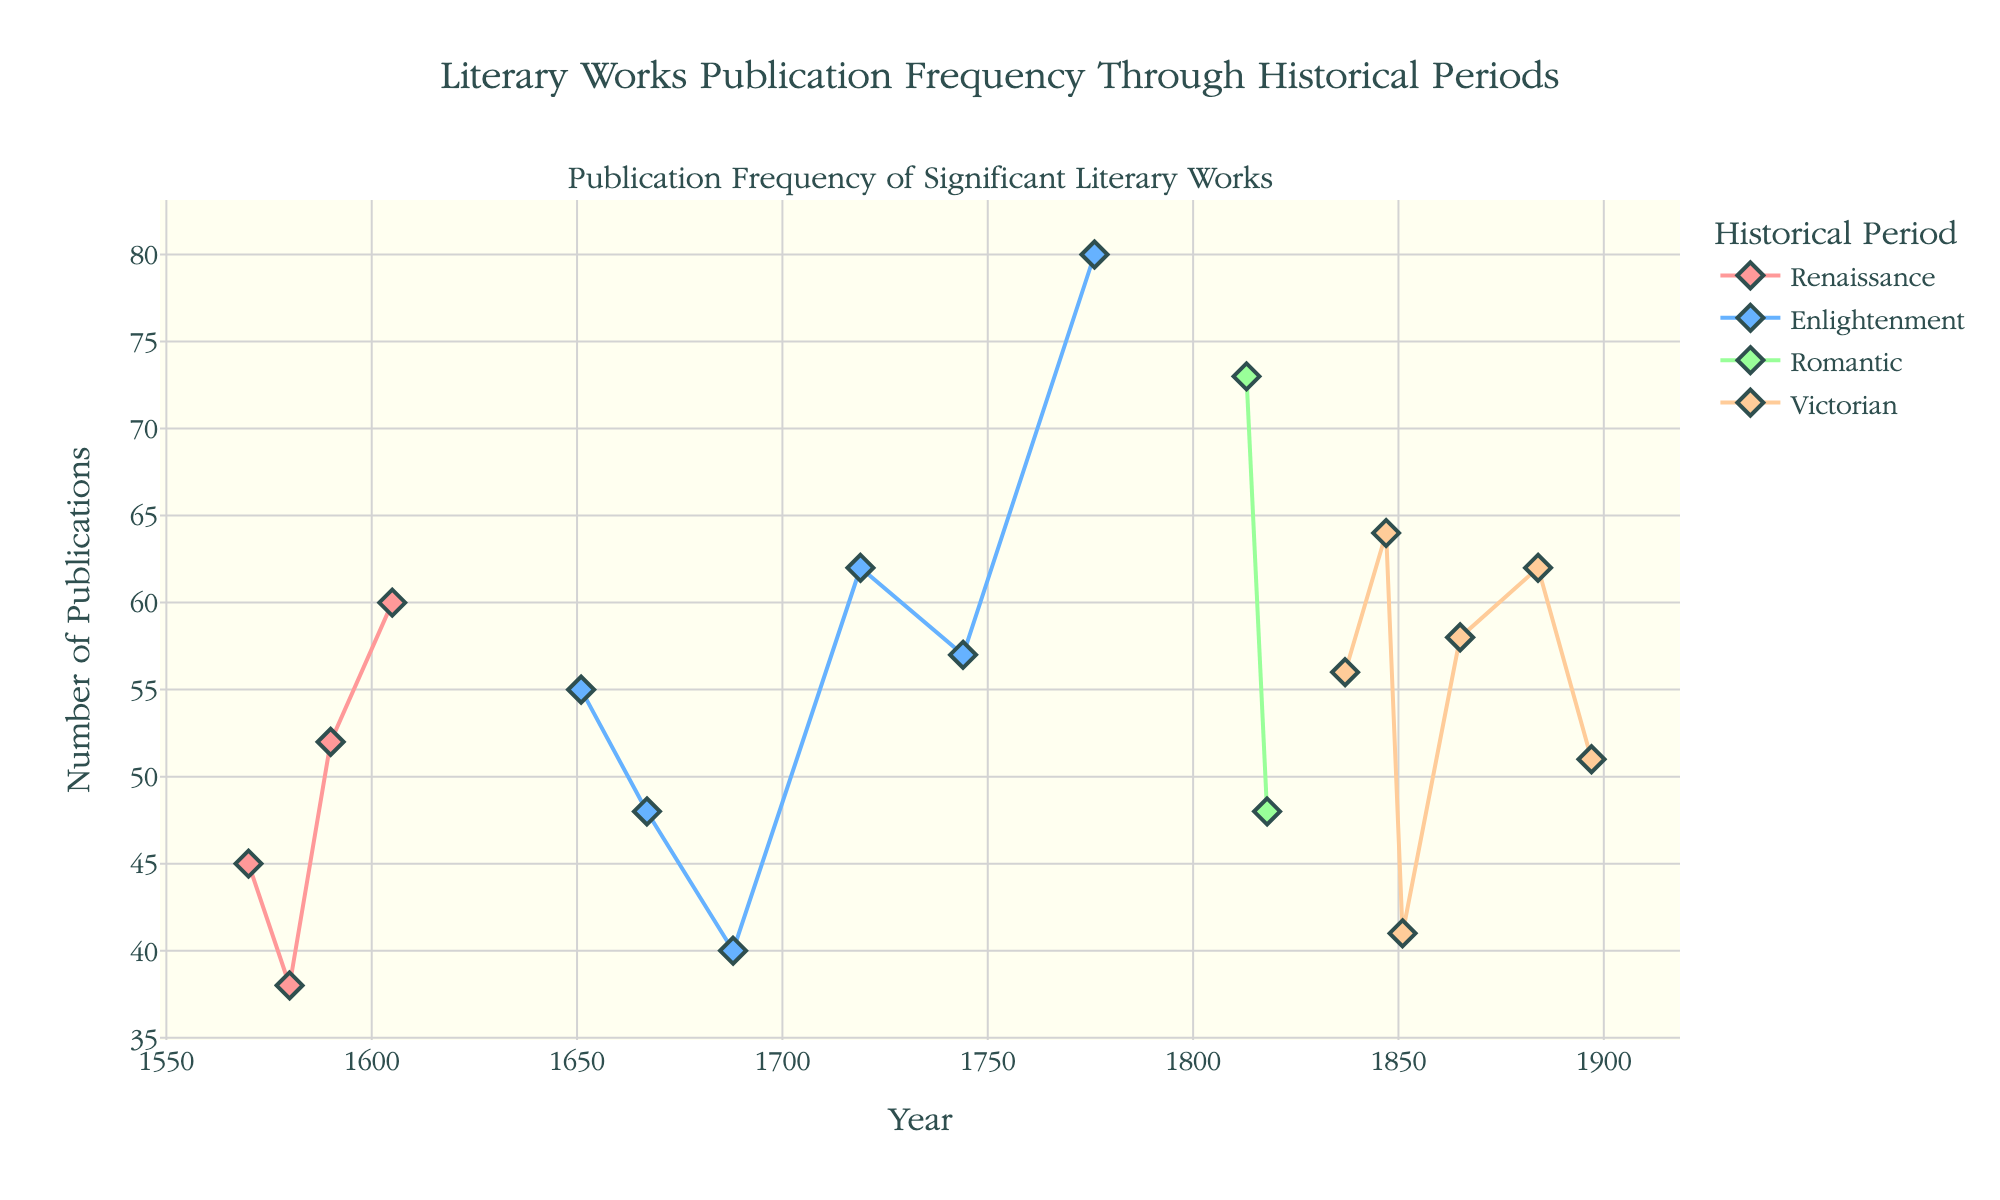Which period has the highest publication frequency for a single work? The chart shows each period's data points representing significant literary works and their publication frequencies. The data point with the highest publication frequency is in the Enlightenment period for "The Declaration of Independence" with 80 publications.
Answer: Enlightenment Which work published in the Victorian era has the highest publication frequency? By looking at the Victorian era's data points, "Jane Eyre" stands out with 64 publications, which is the highest within the Victorian period.
Answer: Jane Eyre What is the average number of publications for Renaissance works? The publication numbers for Renaissance works are 45, 38, 52, and 60. Adding these gives 195, and there are 4 works. Divide 195 by 4 to get the average. (195 / 4 = 48.75)
Answer: 48.75 How many significant literary works are represented in the Enlightenment period? Count the number of data points in the Enlightenment section of the chart. The data shows there are 6 works: Leviathan, Paradise Lost, Oroonoko, Robinson Crusoe, Clarissa, and The Declaration of Independence.
Answer: 6 Is there any significant overlap in publication frequencies between the Romantic and Victorian periods? Compare the ranges of the publication frequencies for both periods. Romantic period ranges from 48 (Frankenstein) to 73 (Pride and Prejudice). Victorian ranges from 41 (Moby-Dick) to 64 (Jane Eyre). Both periods have overlap between the values 48 and 64.
Answer: Yes Which literary work has the lowest number of publications and in which period does it belong? The data point with the lowest publication number is "The Shepheardes Calender" with 38 publications, which belongs to the Renaissance period.
Answer: The Shepheardes Calender, Renaissance Which historical period has the most variation in the number of publications among its works? Variation can be deduced from the range of publication numbers. Enlightenment's range is from 40 (Oroonoko) to 80 (The Declaration of Independence), giving a range of 40. This is the highest variation among all periods.
Answer: Enlightenment How many publications does "Oliver Twist" have, and in which year was it published? For "Oliver Twist," the data shows a publication frequency of 56 and it was published in 1837.
Answer: 56, 1837 What is the overall trend in publication frequencies from the Renaissance to the Victorian era? Observing the chart, publication frequencies seem to generally increase from the Renaissance to the Victorian era with some fluctuations, such as higher publications in the Enlightenment and a peak during the Romantic period.
Answer: Increasing trend 